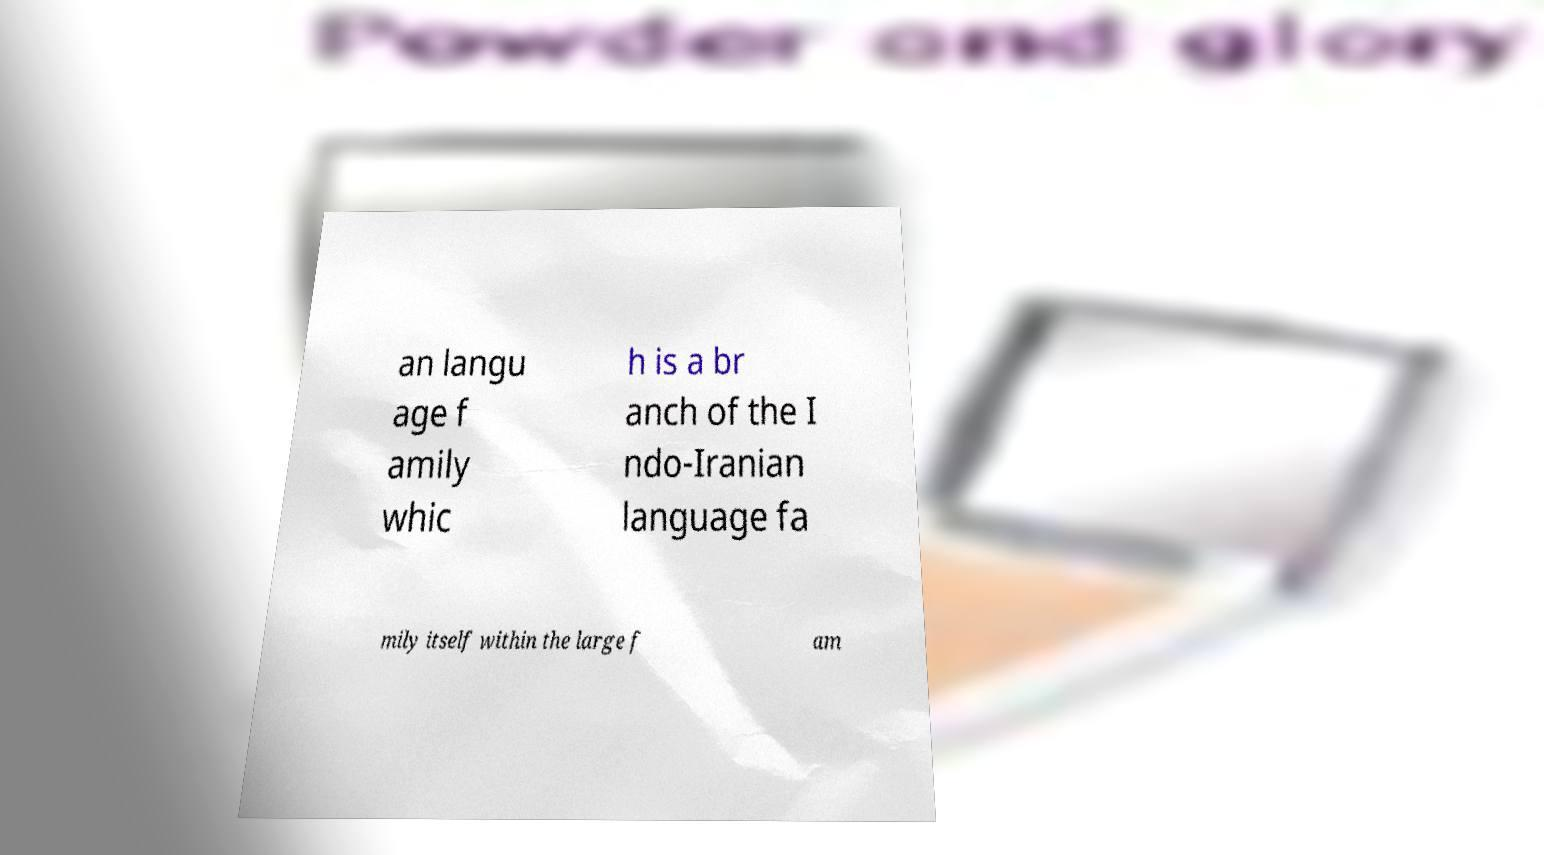I need the written content from this picture converted into text. Can you do that? an langu age f amily whic h is a br anch of the I ndo-Iranian language fa mily itself within the large f am 